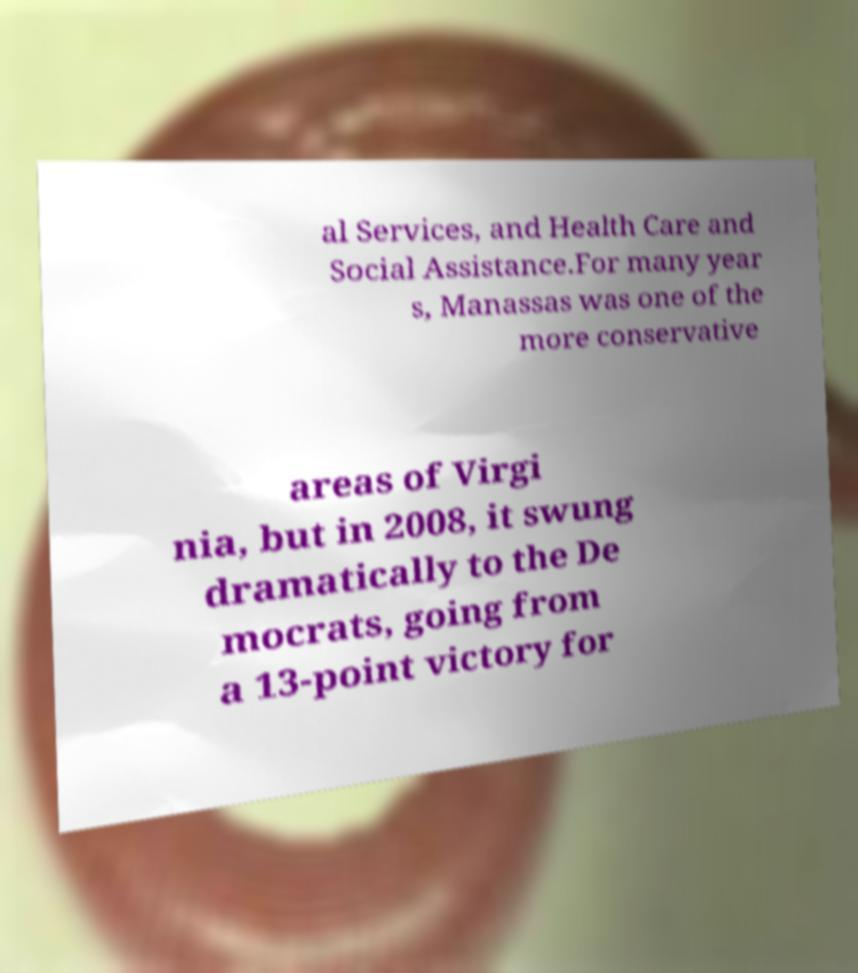Could you assist in decoding the text presented in this image and type it out clearly? al Services, and Health Care and Social Assistance.For many year s, Manassas was one of the more conservative areas of Virgi nia, but in 2008, it swung dramatically to the De mocrats, going from a 13-point victory for 